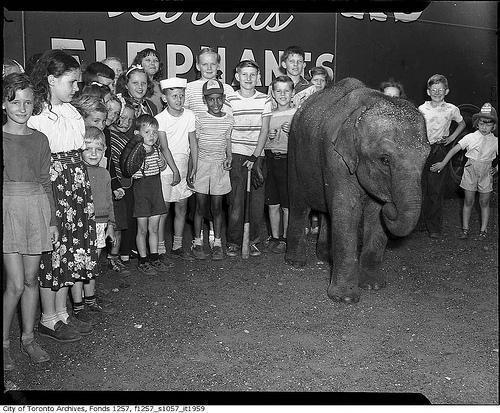How many elephants in there?
Give a very brief answer. 1. 